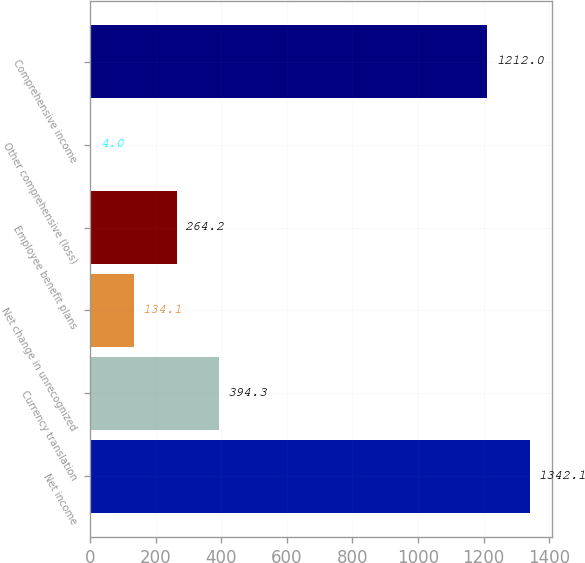Convert chart. <chart><loc_0><loc_0><loc_500><loc_500><bar_chart><fcel>Net income<fcel>Currency translation<fcel>Net change in unrecognized<fcel>Employee benefit plans<fcel>Other comprehensive (loss)<fcel>Comprehensive income<nl><fcel>1342.1<fcel>394.3<fcel>134.1<fcel>264.2<fcel>4<fcel>1212<nl></chart> 